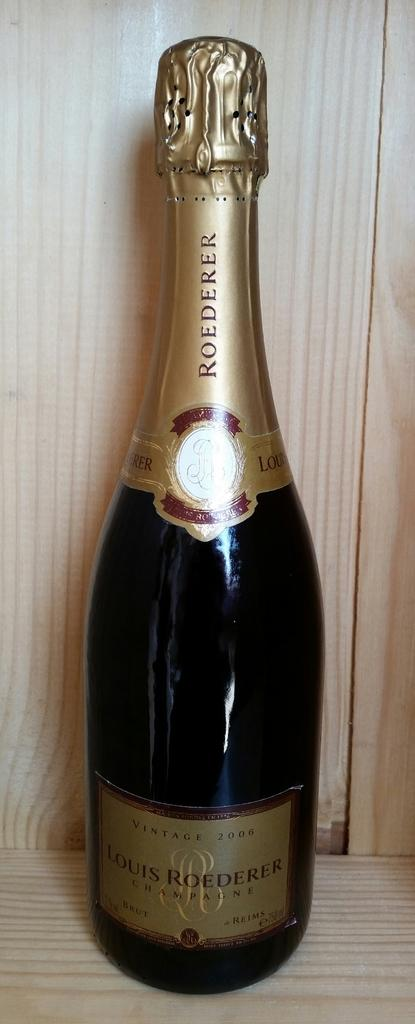<image>
Render a clear and concise summary of the photo. Unopened Roederer wine bottle sitting on a wooden platform. 